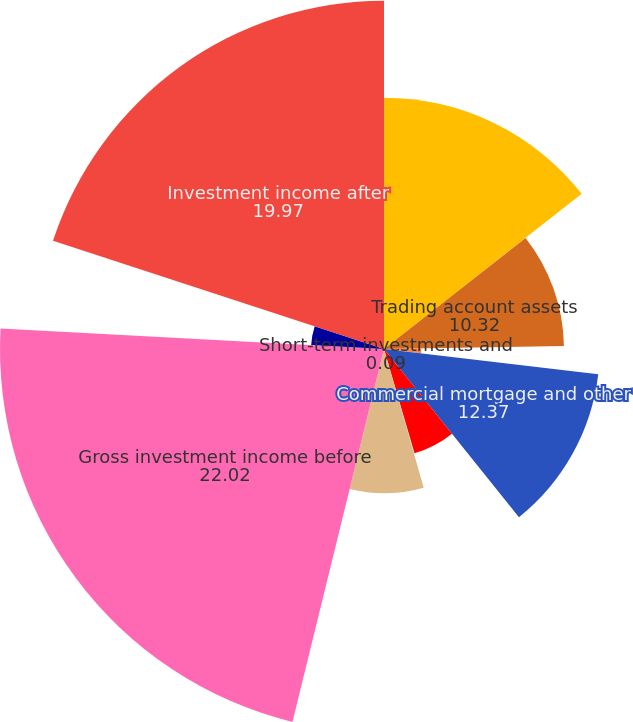Convert chart. <chart><loc_0><loc_0><loc_500><loc_500><pie_chart><fcel>Fixed maturities<fcel>Trading account assets<fcel>Equity securities<fcel>Commercial mortgage and other<fcel>Policy loans<fcel>Short-term investments and<fcel>Other investments<fcel>Gross investment income before<fcel>Investment expenses<fcel>Investment income after<nl><fcel>14.41%<fcel>10.32%<fcel>2.14%<fcel>12.37%<fcel>6.23%<fcel>0.09%<fcel>8.27%<fcel>22.02%<fcel>4.18%<fcel>19.97%<nl></chart> 